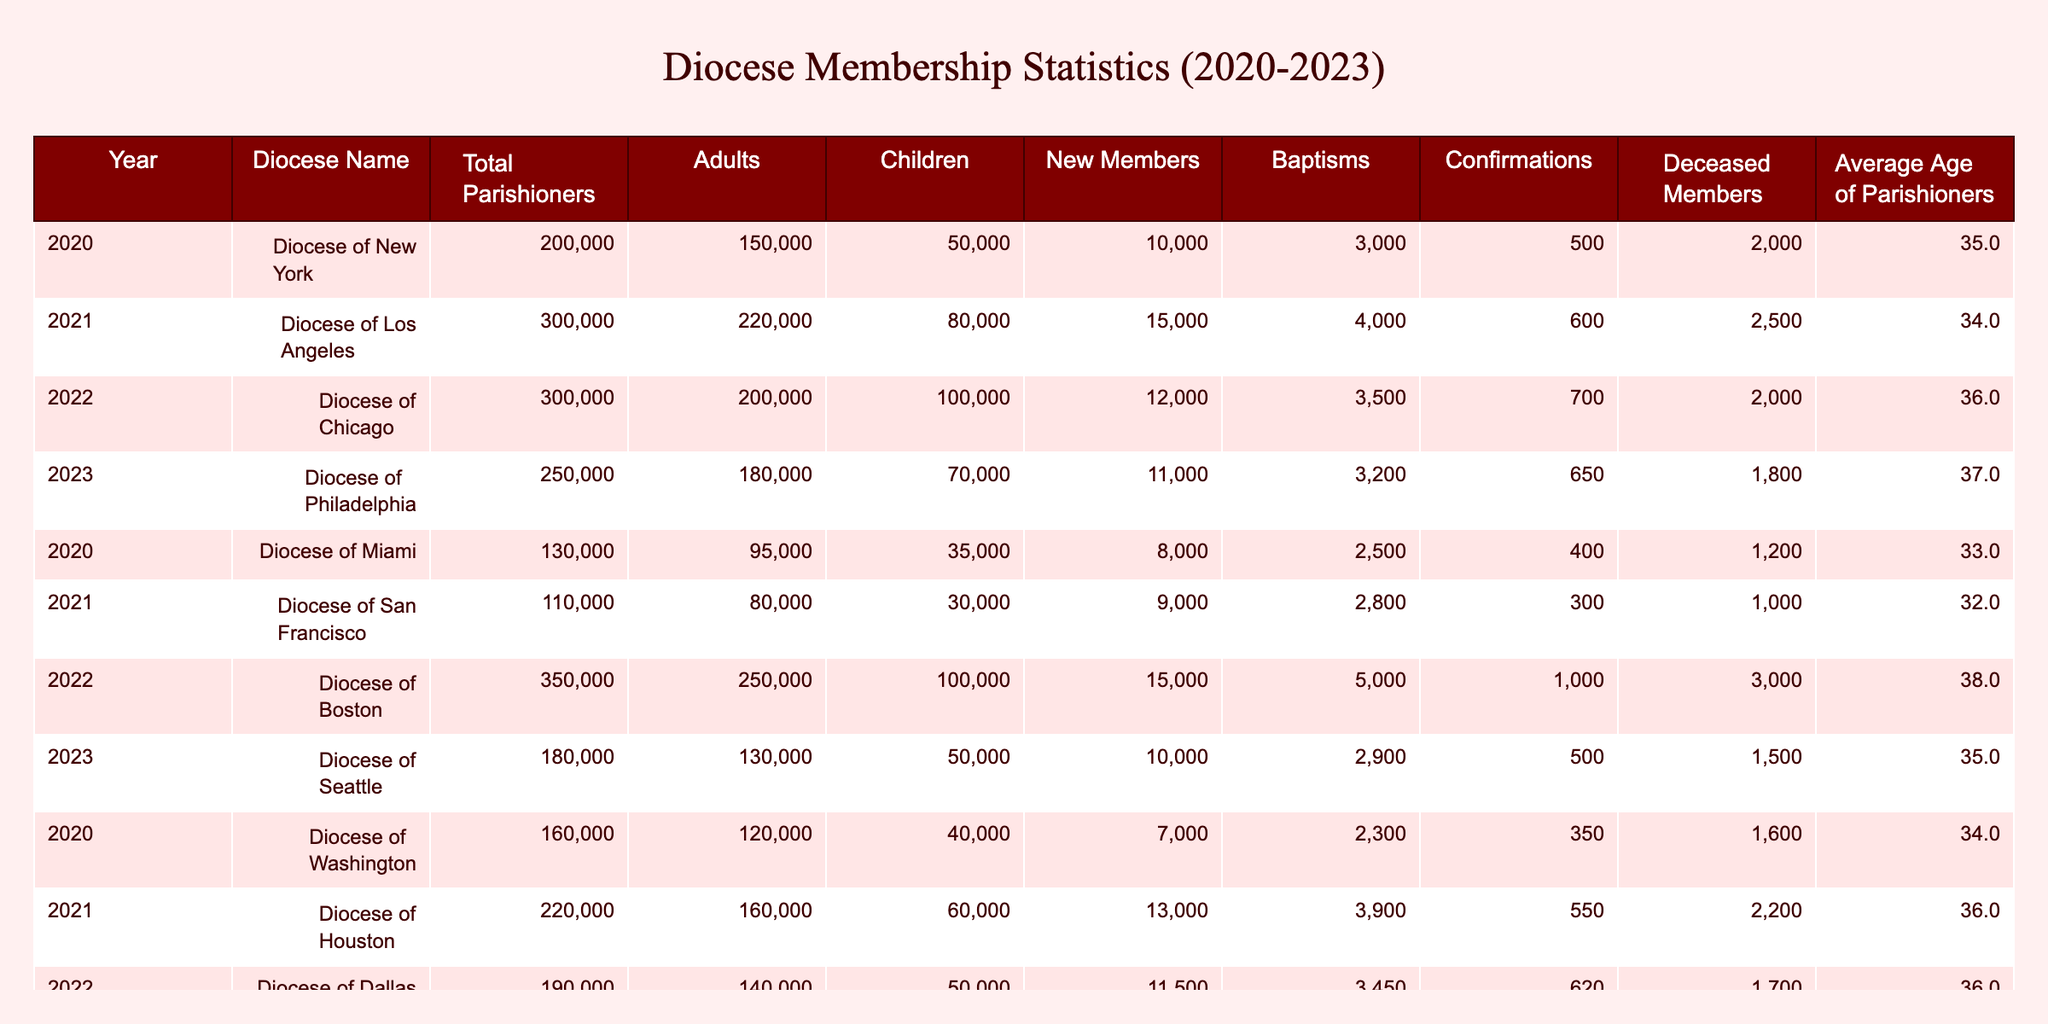What was the total number of parishioners in the Diocese of Chicago in 2022? The table shows that in the year 2022, the Diocese of Chicago had a total of 300,000 parishioners.
Answer: 300000 What is the average age of parishioners in the Diocese of Seattle for 2023? Referring to the table, the average age of parishioners in the Diocese of Seattle in 2023 is 35 years.
Answer: 35 Did the Diocese of Boston have more baptisms than the Diocese of New York in 2022? According to the table, the Diocese of Boston had 5,000 baptisms in 2022, while the Diocese of New York had 3,000 baptisms in 2020. Thus, the Diocese of Boston had more baptisms than the Diocese of New York for the years provided.
Answer: Yes Which diocese had the highest number of total parishioners in 2021? The table indicates that in 2021, the Diocese of Los Angeles had the highest number of total parishioners, with 300,000.
Answer: 300000 What is the difference in new members between the Diocese of San Francisco in 2021 and the Diocese of Phoenix in 2023? The table lists 9,000 new members for the Diocese of San Francisco in 2021 and 8,000 for the Diocese of Phoenix in 2023. To find the difference, we calculate 9000 - 8000 = 1000.
Answer: 1000 Was the number of deceased members greater than 600 in the Diocese of Philadelphia in 2023? According to the table, the Diocese of Philadelphia had 650 deceased members in 2023, which is indeed greater than 600.
Answer: Yes What was the total number of children in the Diocese of Miami in 2020? The table shows that in 2020, the Diocese of Miami had 35,000 children.
Answer: 35000 How many members were confirmed in the Diocese of Dallas compared to the Diocese of Houston in 2021? The table shows that the Diocese of Dallas had 620 confirmations in 2022, and the Diocese of Houston had 550 confirmations in 2021. Since the query is about comparing the two years and not total, we're comparing 620 to 550. 620 is greater than 550.
Answer: 70 more Which diocese saw the lowest number of new members in 2022 compared to 2020? The Diocese of Philadelphia showed 11,000 new members in 2023 with a substantially lower count compared to previous years, while the Diocese of Miami had 8,000 new members in 2020, which is lower than all other dioceses. The Diocese of Miami had the lowest new members for that year.
Answer: Diocese of Miami 